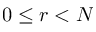Convert formula to latex. <formula><loc_0><loc_0><loc_500><loc_500>0 \leq r < N</formula> 